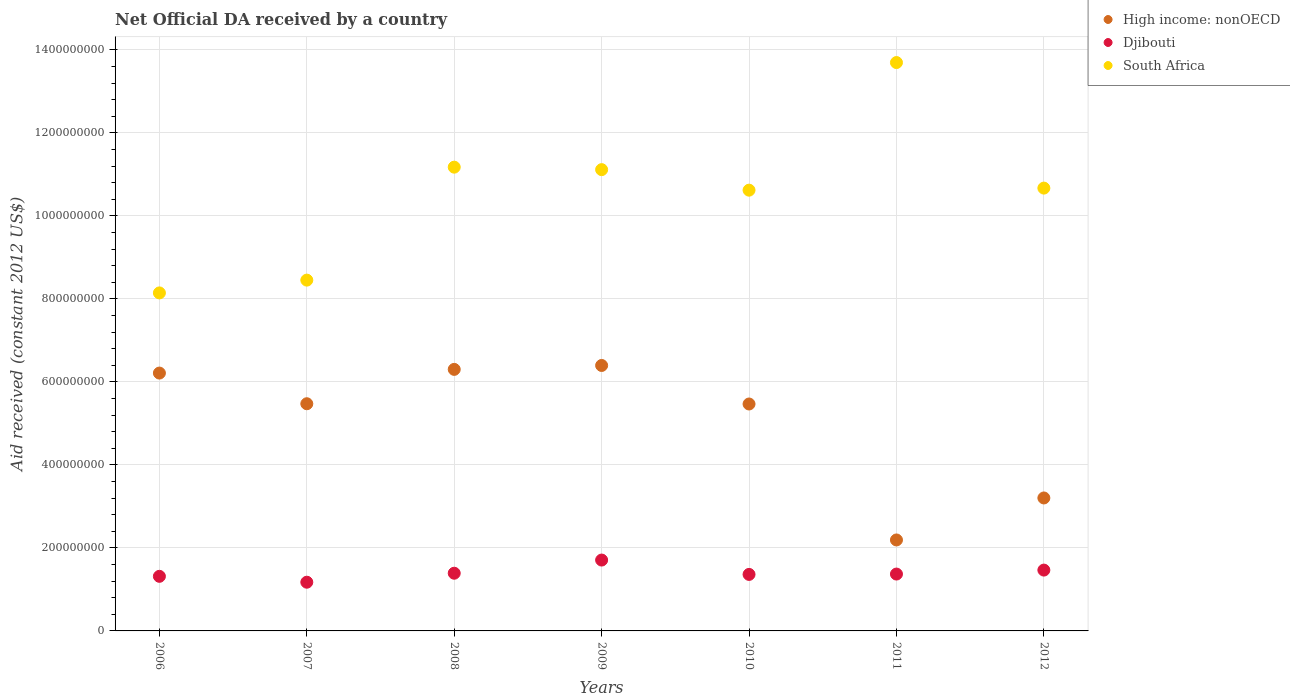Is the number of dotlines equal to the number of legend labels?
Your answer should be compact. Yes. What is the net official development assistance aid received in Djibouti in 2011?
Offer a terse response. 1.37e+08. Across all years, what is the maximum net official development assistance aid received in Djibouti?
Your answer should be compact. 1.71e+08. Across all years, what is the minimum net official development assistance aid received in Djibouti?
Keep it short and to the point. 1.17e+08. What is the total net official development assistance aid received in Djibouti in the graph?
Provide a short and direct response. 9.79e+08. What is the difference between the net official development assistance aid received in South Africa in 2008 and that in 2010?
Make the answer very short. 5.54e+07. What is the difference between the net official development assistance aid received in Djibouti in 2011 and the net official development assistance aid received in South Africa in 2009?
Give a very brief answer. -9.75e+08. What is the average net official development assistance aid received in Djibouti per year?
Make the answer very short. 1.40e+08. In the year 2008, what is the difference between the net official development assistance aid received in High income: nonOECD and net official development assistance aid received in Djibouti?
Your answer should be very brief. 4.91e+08. What is the ratio of the net official development assistance aid received in South Africa in 2007 to that in 2010?
Make the answer very short. 0.8. Is the difference between the net official development assistance aid received in High income: nonOECD in 2006 and 2012 greater than the difference between the net official development assistance aid received in Djibouti in 2006 and 2012?
Your answer should be compact. Yes. What is the difference between the highest and the second highest net official development assistance aid received in South Africa?
Offer a very short reply. 2.52e+08. What is the difference between the highest and the lowest net official development assistance aid received in High income: nonOECD?
Give a very brief answer. 4.20e+08. In how many years, is the net official development assistance aid received in Djibouti greater than the average net official development assistance aid received in Djibouti taken over all years?
Ensure brevity in your answer.  2. Does the net official development assistance aid received in South Africa monotonically increase over the years?
Keep it short and to the point. No. Is the net official development assistance aid received in High income: nonOECD strictly greater than the net official development assistance aid received in Djibouti over the years?
Provide a short and direct response. Yes. Is the net official development assistance aid received in South Africa strictly less than the net official development assistance aid received in Djibouti over the years?
Provide a succinct answer. No. What is the difference between two consecutive major ticks on the Y-axis?
Offer a terse response. 2.00e+08. How are the legend labels stacked?
Ensure brevity in your answer.  Vertical. What is the title of the graph?
Offer a very short reply. Net Official DA received by a country. What is the label or title of the X-axis?
Ensure brevity in your answer.  Years. What is the label or title of the Y-axis?
Give a very brief answer. Aid received (constant 2012 US$). What is the Aid received (constant 2012 US$) in High income: nonOECD in 2006?
Give a very brief answer. 6.21e+08. What is the Aid received (constant 2012 US$) in Djibouti in 2006?
Provide a short and direct response. 1.32e+08. What is the Aid received (constant 2012 US$) in South Africa in 2006?
Your answer should be very brief. 8.15e+08. What is the Aid received (constant 2012 US$) of High income: nonOECD in 2007?
Make the answer very short. 5.47e+08. What is the Aid received (constant 2012 US$) of Djibouti in 2007?
Ensure brevity in your answer.  1.17e+08. What is the Aid received (constant 2012 US$) of South Africa in 2007?
Your answer should be very brief. 8.45e+08. What is the Aid received (constant 2012 US$) in High income: nonOECD in 2008?
Give a very brief answer. 6.30e+08. What is the Aid received (constant 2012 US$) of Djibouti in 2008?
Keep it short and to the point. 1.39e+08. What is the Aid received (constant 2012 US$) in South Africa in 2008?
Offer a very short reply. 1.12e+09. What is the Aid received (constant 2012 US$) in High income: nonOECD in 2009?
Offer a terse response. 6.40e+08. What is the Aid received (constant 2012 US$) in Djibouti in 2009?
Offer a terse response. 1.71e+08. What is the Aid received (constant 2012 US$) in South Africa in 2009?
Offer a very short reply. 1.11e+09. What is the Aid received (constant 2012 US$) of High income: nonOECD in 2010?
Your answer should be very brief. 5.47e+08. What is the Aid received (constant 2012 US$) in Djibouti in 2010?
Offer a very short reply. 1.36e+08. What is the Aid received (constant 2012 US$) of South Africa in 2010?
Your response must be concise. 1.06e+09. What is the Aid received (constant 2012 US$) of High income: nonOECD in 2011?
Ensure brevity in your answer.  2.19e+08. What is the Aid received (constant 2012 US$) in Djibouti in 2011?
Provide a short and direct response. 1.37e+08. What is the Aid received (constant 2012 US$) of South Africa in 2011?
Your response must be concise. 1.37e+09. What is the Aid received (constant 2012 US$) in High income: nonOECD in 2012?
Provide a short and direct response. 3.20e+08. What is the Aid received (constant 2012 US$) of Djibouti in 2012?
Provide a succinct answer. 1.47e+08. What is the Aid received (constant 2012 US$) of South Africa in 2012?
Offer a very short reply. 1.07e+09. Across all years, what is the maximum Aid received (constant 2012 US$) of High income: nonOECD?
Keep it short and to the point. 6.40e+08. Across all years, what is the maximum Aid received (constant 2012 US$) of Djibouti?
Your answer should be very brief. 1.71e+08. Across all years, what is the maximum Aid received (constant 2012 US$) of South Africa?
Your answer should be very brief. 1.37e+09. Across all years, what is the minimum Aid received (constant 2012 US$) of High income: nonOECD?
Provide a short and direct response. 2.19e+08. Across all years, what is the minimum Aid received (constant 2012 US$) in Djibouti?
Offer a terse response. 1.17e+08. Across all years, what is the minimum Aid received (constant 2012 US$) of South Africa?
Give a very brief answer. 8.15e+08. What is the total Aid received (constant 2012 US$) of High income: nonOECD in the graph?
Offer a very short reply. 3.53e+09. What is the total Aid received (constant 2012 US$) of Djibouti in the graph?
Give a very brief answer. 9.79e+08. What is the total Aid received (constant 2012 US$) in South Africa in the graph?
Provide a short and direct response. 7.39e+09. What is the difference between the Aid received (constant 2012 US$) in High income: nonOECD in 2006 and that in 2007?
Provide a short and direct response. 7.39e+07. What is the difference between the Aid received (constant 2012 US$) in Djibouti in 2006 and that in 2007?
Ensure brevity in your answer.  1.42e+07. What is the difference between the Aid received (constant 2012 US$) in South Africa in 2006 and that in 2007?
Provide a succinct answer. -3.08e+07. What is the difference between the Aid received (constant 2012 US$) of High income: nonOECD in 2006 and that in 2008?
Offer a very short reply. -8.90e+06. What is the difference between the Aid received (constant 2012 US$) in Djibouti in 2006 and that in 2008?
Make the answer very short. -7.46e+06. What is the difference between the Aid received (constant 2012 US$) in South Africa in 2006 and that in 2008?
Provide a succinct answer. -3.03e+08. What is the difference between the Aid received (constant 2012 US$) in High income: nonOECD in 2006 and that in 2009?
Ensure brevity in your answer.  -1.83e+07. What is the difference between the Aid received (constant 2012 US$) in Djibouti in 2006 and that in 2009?
Give a very brief answer. -3.92e+07. What is the difference between the Aid received (constant 2012 US$) in South Africa in 2006 and that in 2009?
Give a very brief answer. -2.97e+08. What is the difference between the Aid received (constant 2012 US$) in High income: nonOECD in 2006 and that in 2010?
Your answer should be very brief. 7.45e+07. What is the difference between the Aid received (constant 2012 US$) of Djibouti in 2006 and that in 2010?
Provide a short and direct response. -4.60e+06. What is the difference between the Aid received (constant 2012 US$) of South Africa in 2006 and that in 2010?
Offer a very short reply. -2.48e+08. What is the difference between the Aid received (constant 2012 US$) of High income: nonOECD in 2006 and that in 2011?
Offer a very short reply. 4.02e+08. What is the difference between the Aid received (constant 2012 US$) of Djibouti in 2006 and that in 2011?
Provide a short and direct response. -5.45e+06. What is the difference between the Aid received (constant 2012 US$) of South Africa in 2006 and that in 2011?
Provide a short and direct response. -5.55e+08. What is the difference between the Aid received (constant 2012 US$) of High income: nonOECD in 2006 and that in 2012?
Your answer should be compact. 3.01e+08. What is the difference between the Aid received (constant 2012 US$) of Djibouti in 2006 and that in 2012?
Provide a succinct answer. -1.50e+07. What is the difference between the Aid received (constant 2012 US$) in South Africa in 2006 and that in 2012?
Offer a very short reply. -2.53e+08. What is the difference between the Aid received (constant 2012 US$) of High income: nonOECD in 2007 and that in 2008?
Give a very brief answer. -8.28e+07. What is the difference between the Aid received (constant 2012 US$) of Djibouti in 2007 and that in 2008?
Ensure brevity in your answer.  -2.16e+07. What is the difference between the Aid received (constant 2012 US$) in South Africa in 2007 and that in 2008?
Your answer should be compact. -2.72e+08. What is the difference between the Aid received (constant 2012 US$) of High income: nonOECD in 2007 and that in 2009?
Ensure brevity in your answer.  -9.22e+07. What is the difference between the Aid received (constant 2012 US$) in Djibouti in 2007 and that in 2009?
Your answer should be compact. -5.34e+07. What is the difference between the Aid received (constant 2012 US$) in South Africa in 2007 and that in 2009?
Provide a succinct answer. -2.66e+08. What is the difference between the Aid received (constant 2012 US$) of High income: nonOECD in 2007 and that in 2010?
Offer a terse response. 6.30e+05. What is the difference between the Aid received (constant 2012 US$) of Djibouti in 2007 and that in 2010?
Give a very brief answer. -1.88e+07. What is the difference between the Aid received (constant 2012 US$) of South Africa in 2007 and that in 2010?
Offer a very short reply. -2.17e+08. What is the difference between the Aid received (constant 2012 US$) in High income: nonOECD in 2007 and that in 2011?
Make the answer very short. 3.28e+08. What is the difference between the Aid received (constant 2012 US$) of Djibouti in 2007 and that in 2011?
Make the answer very short. -1.96e+07. What is the difference between the Aid received (constant 2012 US$) of South Africa in 2007 and that in 2011?
Ensure brevity in your answer.  -5.24e+08. What is the difference between the Aid received (constant 2012 US$) of High income: nonOECD in 2007 and that in 2012?
Give a very brief answer. 2.27e+08. What is the difference between the Aid received (constant 2012 US$) of Djibouti in 2007 and that in 2012?
Offer a terse response. -2.92e+07. What is the difference between the Aid received (constant 2012 US$) of South Africa in 2007 and that in 2012?
Keep it short and to the point. -2.22e+08. What is the difference between the Aid received (constant 2012 US$) of High income: nonOECD in 2008 and that in 2009?
Ensure brevity in your answer.  -9.43e+06. What is the difference between the Aid received (constant 2012 US$) of Djibouti in 2008 and that in 2009?
Your response must be concise. -3.17e+07. What is the difference between the Aid received (constant 2012 US$) in South Africa in 2008 and that in 2009?
Ensure brevity in your answer.  5.98e+06. What is the difference between the Aid received (constant 2012 US$) in High income: nonOECD in 2008 and that in 2010?
Offer a very short reply. 8.34e+07. What is the difference between the Aid received (constant 2012 US$) in Djibouti in 2008 and that in 2010?
Offer a very short reply. 2.86e+06. What is the difference between the Aid received (constant 2012 US$) of South Africa in 2008 and that in 2010?
Your answer should be compact. 5.54e+07. What is the difference between the Aid received (constant 2012 US$) of High income: nonOECD in 2008 and that in 2011?
Your response must be concise. 4.11e+08. What is the difference between the Aid received (constant 2012 US$) of Djibouti in 2008 and that in 2011?
Offer a terse response. 2.01e+06. What is the difference between the Aid received (constant 2012 US$) of South Africa in 2008 and that in 2011?
Give a very brief answer. -2.52e+08. What is the difference between the Aid received (constant 2012 US$) in High income: nonOECD in 2008 and that in 2012?
Your response must be concise. 3.10e+08. What is the difference between the Aid received (constant 2012 US$) of Djibouti in 2008 and that in 2012?
Give a very brief answer. -7.55e+06. What is the difference between the Aid received (constant 2012 US$) of South Africa in 2008 and that in 2012?
Offer a terse response. 5.05e+07. What is the difference between the Aid received (constant 2012 US$) of High income: nonOECD in 2009 and that in 2010?
Keep it short and to the point. 9.29e+07. What is the difference between the Aid received (constant 2012 US$) in Djibouti in 2009 and that in 2010?
Provide a short and direct response. 3.46e+07. What is the difference between the Aid received (constant 2012 US$) in South Africa in 2009 and that in 2010?
Your answer should be compact. 4.95e+07. What is the difference between the Aid received (constant 2012 US$) in High income: nonOECD in 2009 and that in 2011?
Make the answer very short. 4.20e+08. What is the difference between the Aid received (constant 2012 US$) of Djibouti in 2009 and that in 2011?
Your answer should be very brief. 3.38e+07. What is the difference between the Aid received (constant 2012 US$) of South Africa in 2009 and that in 2011?
Your response must be concise. -2.58e+08. What is the difference between the Aid received (constant 2012 US$) in High income: nonOECD in 2009 and that in 2012?
Ensure brevity in your answer.  3.19e+08. What is the difference between the Aid received (constant 2012 US$) in Djibouti in 2009 and that in 2012?
Provide a succinct answer. 2.42e+07. What is the difference between the Aid received (constant 2012 US$) of South Africa in 2009 and that in 2012?
Offer a very short reply. 4.45e+07. What is the difference between the Aid received (constant 2012 US$) in High income: nonOECD in 2010 and that in 2011?
Offer a very short reply. 3.28e+08. What is the difference between the Aid received (constant 2012 US$) of Djibouti in 2010 and that in 2011?
Your answer should be compact. -8.50e+05. What is the difference between the Aid received (constant 2012 US$) in South Africa in 2010 and that in 2011?
Ensure brevity in your answer.  -3.08e+08. What is the difference between the Aid received (constant 2012 US$) in High income: nonOECD in 2010 and that in 2012?
Offer a very short reply. 2.26e+08. What is the difference between the Aid received (constant 2012 US$) in Djibouti in 2010 and that in 2012?
Keep it short and to the point. -1.04e+07. What is the difference between the Aid received (constant 2012 US$) in South Africa in 2010 and that in 2012?
Give a very brief answer. -4.97e+06. What is the difference between the Aid received (constant 2012 US$) of High income: nonOECD in 2011 and that in 2012?
Provide a short and direct response. -1.01e+08. What is the difference between the Aid received (constant 2012 US$) of Djibouti in 2011 and that in 2012?
Offer a very short reply. -9.56e+06. What is the difference between the Aid received (constant 2012 US$) in South Africa in 2011 and that in 2012?
Keep it short and to the point. 3.03e+08. What is the difference between the Aid received (constant 2012 US$) in High income: nonOECD in 2006 and the Aid received (constant 2012 US$) in Djibouti in 2007?
Your answer should be very brief. 5.04e+08. What is the difference between the Aid received (constant 2012 US$) of High income: nonOECD in 2006 and the Aid received (constant 2012 US$) of South Africa in 2007?
Ensure brevity in your answer.  -2.24e+08. What is the difference between the Aid received (constant 2012 US$) of Djibouti in 2006 and the Aid received (constant 2012 US$) of South Africa in 2007?
Make the answer very short. -7.14e+08. What is the difference between the Aid received (constant 2012 US$) in High income: nonOECD in 2006 and the Aid received (constant 2012 US$) in Djibouti in 2008?
Your answer should be very brief. 4.82e+08. What is the difference between the Aid received (constant 2012 US$) in High income: nonOECD in 2006 and the Aid received (constant 2012 US$) in South Africa in 2008?
Offer a very short reply. -4.96e+08. What is the difference between the Aid received (constant 2012 US$) in Djibouti in 2006 and the Aid received (constant 2012 US$) in South Africa in 2008?
Make the answer very short. -9.86e+08. What is the difference between the Aid received (constant 2012 US$) in High income: nonOECD in 2006 and the Aid received (constant 2012 US$) in Djibouti in 2009?
Ensure brevity in your answer.  4.51e+08. What is the difference between the Aid received (constant 2012 US$) in High income: nonOECD in 2006 and the Aid received (constant 2012 US$) in South Africa in 2009?
Keep it short and to the point. -4.90e+08. What is the difference between the Aid received (constant 2012 US$) in Djibouti in 2006 and the Aid received (constant 2012 US$) in South Africa in 2009?
Provide a short and direct response. -9.80e+08. What is the difference between the Aid received (constant 2012 US$) of High income: nonOECD in 2006 and the Aid received (constant 2012 US$) of Djibouti in 2010?
Make the answer very short. 4.85e+08. What is the difference between the Aid received (constant 2012 US$) of High income: nonOECD in 2006 and the Aid received (constant 2012 US$) of South Africa in 2010?
Ensure brevity in your answer.  -4.41e+08. What is the difference between the Aid received (constant 2012 US$) in Djibouti in 2006 and the Aid received (constant 2012 US$) in South Africa in 2010?
Make the answer very short. -9.31e+08. What is the difference between the Aid received (constant 2012 US$) in High income: nonOECD in 2006 and the Aid received (constant 2012 US$) in Djibouti in 2011?
Provide a succinct answer. 4.84e+08. What is the difference between the Aid received (constant 2012 US$) of High income: nonOECD in 2006 and the Aid received (constant 2012 US$) of South Africa in 2011?
Keep it short and to the point. -7.48e+08. What is the difference between the Aid received (constant 2012 US$) of Djibouti in 2006 and the Aid received (constant 2012 US$) of South Africa in 2011?
Give a very brief answer. -1.24e+09. What is the difference between the Aid received (constant 2012 US$) in High income: nonOECD in 2006 and the Aid received (constant 2012 US$) in Djibouti in 2012?
Ensure brevity in your answer.  4.75e+08. What is the difference between the Aid received (constant 2012 US$) of High income: nonOECD in 2006 and the Aid received (constant 2012 US$) of South Africa in 2012?
Ensure brevity in your answer.  -4.46e+08. What is the difference between the Aid received (constant 2012 US$) of Djibouti in 2006 and the Aid received (constant 2012 US$) of South Africa in 2012?
Provide a short and direct response. -9.36e+08. What is the difference between the Aid received (constant 2012 US$) of High income: nonOECD in 2007 and the Aid received (constant 2012 US$) of Djibouti in 2008?
Your answer should be very brief. 4.08e+08. What is the difference between the Aid received (constant 2012 US$) of High income: nonOECD in 2007 and the Aid received (constant 2012 US$) of South Africa in 2008?
Give a very brief answer. -5.70e+08. What is the difference between the Aid received (constant 2012 US$) of Djibouti in 2007 and the Aid received (constant 2012 US$) of South Africa in 2008?
Keep it short and to the point. -1.00e+09. What is the difference between the Aid received (constant 2012 US$) in High income: nonOECD in 2007 and the Aid received (constant 2012 US$) in Djibouti in 2009?
Your answer should be compact. 3.77e+08. What is the difference between the Aid received (constant 2012 US$) of High income: nonOECD in 2007 and the Aid received (constant 2012 US$) of South Africa in 2009?
Your answer should be very brief. -5.64e+08. What is the difference between the Aid received (constant 2012 US$) of Djibouti in 2007 and the Aid received (constant 2012 US$) of South Africa in 2009?
Give a very brief answer. -9.94e+08. What is the difference between the Aid received (constant 2012 US$) of High income: nonOECD in 2007 and the Aid received (constant 2012 US$) of Djibouti in 2010?
Ensure brevity in your answer.  4.11e+08. What is the difference between the Aid received (constant 2012 US$) of High income: nonOECD in 2007 and the Aid received (constant 2012 US$) of South Africa in 2010?
Offer a terse response. -5.15e+08. What is the difference between the Aid received (constant 2012 US$) in Djibouti in 2007 and the Aid received (constant 2012 US$) in South Africa in 2010?
Ensure brevity in your answer.  -9.45e+08. What is the difference between the Aid received (constant 2012 US$) of High income: nonOECD in 2007 and the Aid received (constant 2012 US$) of Djibouti in 2011?
Give a very brief answer. 4.10e+08. What is the difference between the Aid received (constant 2012 US$) in High income: nonOECD in 2007 and the Aid received (constant 2012 US$) in South Africa in 2011?
Offer a very short reply. -8.22e+08. What is the difference between the Aid received (constant 2012 US$) in Djibouti in 2007 and the Aid received (constant 2012 US$) in South Africa in 2011?
Offer a terse response. -1.25e+09. What is the difference between the Aid received (constant 2012 US$) in High income: nonOECD in 2007 and the Aid received (constant 2012 US$) in Djibouti in 2012?
Your response must be concise. 4.01e+08. What is the difference between the Aid received (constant 2012 US$) in High income: nonOECD in 2007 and the Aid received (constant 2012 US$) in South Africa in 2012?
Your answer should be compact. -5.20e+08. What is the difference between the Aid received (constant 2012 US$) of Djibouti in 2007 and the Aid received (constant 2012 US$) of South Africa in 2012?
Keep it short and to the point. -9.50e+08. What is the difference between the Aid received (constant 2012 US$) of High income: nonOECD in 2008 and the Aid received (constant 2012 US$) of Djibouti in 2009?
Your response must be concise. 4.60e+08. What is the difference between the Aid received (constant 2012 US$) in High income: nonOECD in 2008 and the Aid received (constant 2012 US$) in South Africa in 2009?
Offer a terse response. -4.81e+08. What is the difference between the Aid received (constant 2012 US$) in Djibouti in 2008 and the Aid received (constant 2012 US$) in South Africa in 2009?
Provide a short and direct response. -9.73e+08. What is the difference between the Aid received (constant 2012 US$) of High income: nonOECD in 2008 and the Aid received (constant 2012 US$) of Djibouti in 2010?
Your answer should be very brief. 4.94e+08. What is the difference between the Aid received (constant 2012 US$) in High income: nonOECD in 2008 and the Aid received (constant 2012 US$) in South Africa in 2010?
Your answer should be very brief. -4.32e+08. What is the difference between the Aid received (constant 2012 US$) in Djibouti in 2008 and the Aid received (constant 2012 US$) in South Africa in 2010?
Your response must be concise. -9.23e+08. What is the difference between the Aid received (constant 2012 US$) of High income: nonOECD in 2008 and the Aid received (constant 2012 US$) of Djibouti in 2011?
Make the answer very short. 4.93e+08. What is the difference between the Aid received (constant 2012 US$) of High income: nonOECD in 2008 and the Aid received (constant 2012 US$) of South Africa in 2011?
Make the answer very short. -7.39e+08. What is the difference between the Aid received (constant 2012 US$) of Djibouti in 2008 and the Aid received (constant 2012 US$) of South Africa in 2011?
Make the answer very short. -1.23e+09. What is the difference between the Aid received (constant 2012 US$) of High income: nonOECD in 2008 and the Aid received (constant 2012 US$) of Djibouti in 2012?
Provide a short and direct response. 4.84e+08. What is the difference between the Aid received (constant 2012 US$) of High income: nonOECD in 2008 and the Aid received (constant 2012 US$) of South Africa in 2012?
Ensure brevity in your answer.  -4.37e+08. What is the difference between the Aid received (constant 2012 US$) of Djibouti in 2008 and the Aid received (constant 2012 US$) of South Africa in 2012?
Your answer should be very brief. -9.28e+08. What is the difference between the Aid received (constant 2012 US$) in High income: nonOECD in 2009 and the Aid received (constant 2012 US$) in Djibouti in 2010?
Your answer should be very brief. 5.04e+08. What is the difference between the Aid received (constant 2012 US$) of High income: nonOECD in 2009 and the Aid received (constant 2012 US$) of South Africa in 2010?
Your answer should be very brief. -4.22e+08. What is the difference between the Aid received (constant 2012 US$) of Djibouti in 2009 and the Aid received (constant 2012 US$) of South Africa in 2010?
Make the answer very short. -8.91e+08. What is the difference between the Aid received (constant 2012 US$) in High income: nonOECD in 2009 and the Aid received (constant 2012 US$) in Djibouti in 2011?
Offer a terse response. 5.03e+08. What is the difference between the Aid received (constant 2012 US$) of High income: nonOECD in 2009 and the Aid received (constant 2012 US$) of South Africa in 2011?
Make the answer very short. -7.30e+08. What is the difference between the Aid received (constant 2012 US$) of Djibouti in 2009 and the Aid received (constant 2012 US$) of South Africa in 2011?
Your answer should be compact. -1.20e+09. What is the difference between the Aid received (constant 2012 US$) in High income: nonOECD in 2009 and the Aid received (constant 2012 US$) in Djibouti in 2012?
Keep it short and to the point. 4.93e+08. What is the difference between the Aid received (constant 2012 US$) of High income: nonOECD in 2009 and the Aid received (constant 2012 US$) of South Africa in 2012?
Provide a succinct answer. -4.27e+08. What is the difference between the Aid received (constant 2012 US$) of Djibouti in 2009 and the Aid received (constant 2012 US$) of South Africa in 2012?
Keep it short and to the point. -8.96e+08. What is the difference between the Aid received (constant 2012 US$) in High income: nonOECD in 2010 and the Aid received (constant 2012 US$) in Djibouti in 2011?
Ensure brevity in your answer.  4.10e+08. What is the difference between the Aid received (constant 2012 US$) in High income: nonOECD in 2010 and the Aid received (constant 2012 US$) in South Africa in 2011?
Make the answer very short. -8.23e+08. What is the difference between the Aid received (constant 2012 US$) of Djibouti in 2010 and the Aid received (constant 2012 US$) of South Africa in 2011?
Your answer should be compact. -1.23e+09. What is the difference between the Aid received (constant 2012 US$) in High income: nonOECD in 2010 and the Aid received (constant 2012 US$) in Djibouti in 2012?
Your answer should be compact. 4.00e+08. What is the difference between the Aid received (constant 2012 US$) of High income: nonOECD in 2010 and the Aid received (constant 2012 US$) of South Africa in 2012?
Provide a short and direct response. -5.20e+08. What is the difference between the Aid received (constant 2012 US$) in Djibouti in 2010 and the Aid received (constant 2012 US$) in South Africa in 2012?
Make the answer very short. -9.31e+08. What is the difference between the Aid received (constant 2012 US$) in High income: nonOECD in 2011 and the Aid received (constant 2012 US$) in Djibouti in 2012?
Your answer should be very brief. 7.26e+07. What is the difference between the Aid received (constant 2012 US$) in High income: nonOECD in 2011 and the Aid received (constant 2012 US$) in South Africa in 2012?
Your response must be concise. -8.48e+08. What is the difference between the Aid received (constant 2012 US$) in Djibouti in 2011 and the Aid received (constant 2012 US$) in South Africa in 2012?
Your response must be concise. -9.30e+08. What is the average Aid received (constant 2012 US$) of High income: nonOECD per year?
Your answer should be very brief. 5.04e+08. What is the average Aid received (constant 2012 US$) in Djibouti per year?
Offer a very short reply. 1.40e+08. What is the average Aid received (constant 2012 US$) in South Africa per year?
Provide a short and direct response. 1.06e+09. In the year 2006, what is the difference between the Aid received (constant 2012 US$) in High income: nonOECD and Aid received (constant 2012 US$) in Djibouti?
Offer a terse response. 4.90e+08. In the year 2006, what is the difference between the Aid received (constant 2012 US$) in High income: nonOECD and Aid received (constant 2012 US$) in South Africa?
Your answer should be very brief. -1.93e+08. In the year 2006, what is the difference between the Aid received (constant 2012 US$) of Djibouti and Aid received (constant 2012 US$) of South Africa?
Your answer should be compact. -6.83e+08. In the year 2007, what is the difference between the Aid received (constant 2012 US$) of High income: nonOECD and Aid received (constant 2012 US$) of Djibouti?
Give a very brief answer. 4.30e+08. In the year 2007, what is the difference between the Aid received (constant 2012 US$) in High income: nonOECD and Aid received (constant 2012 US$) in South Africa?
Your answer should be very brief. -2.98e+08. In the year 2007, what is the difference between the Aid received (constant 2012 US$) of Djibouti and Aid received (constant 2012 US$) of South Africa?
Offer a terse response. -7.28e+08. In the year 2008, what is the difference between the Aid received (constant 2012 US$) of High income: nonOECD and Aid received (constant 2012 US$) of Djibouti?
Provide a short and direct response. 4.91e+08. In the year 2008, what is the difference between the Aid received (constant 2012 US$) in High income: nonOECD and Aid received (constant 2012 US$) in South Africa?
Give a very brief answer. -4.87e+08. In the year 2008, what is the difference between the Aid received (constant 2012 US$) of Djibouti and Aid received (constant 2012 US$) of South Africa?
Make the answer very short. -9.79e+08. In the year 2009, what is the difference between the Aid received (constant 2012 US$) of High income: nonOECD and Aid received (constant 2012 US$) of Djibouti?
Keep it short and to the point. 4.69e+08. In the year 2009, what is the difference between the Aid received (constant 2012 US$) in High income: nonOECD and Aid received (constant 2012 US$) in South Africa?
Provide a succinct answer. -4.72e+08. In the year 2009, what is the difference between the Aid received (constant 2012 US$) in Djibouti and Aid received (constant 2012 US$) in South Africa?
Your response must be concise. -9.41e+08. In the year 2010, what is the difference between the Aid received (constant 2012 US$) in High income: nonOECD and Aid received (constant 2012 US$) in Djibouti?
Make the answer very short. 4.11e+08. In the year 2010, what is the difference between the Aid received (constant 2012 US$) in High income: nonOECD and Aid received (constant 2012 US$) in South Africa?
Offer a very short reply. -5.15e+08. In the year 2010, what is the difference between the Aid received (constant 2012 US$) in Djibouti and Aid received (constant 2012 US$) in South Africa?
Your response must be concise. -9.26e+08. In the year 2011, what is the difference between the Aid received (constant 2012 US$) in High income: nonOECD and Aid received (constant 2012 US$) in Djibouti?
Your answer should be compact. 8.22e+07. In the year 2011, what is the difference between the Aid received (constant 2012 US$) in High income: nonOECD and Aid received (constant 2012 US$) in South Africa?
Your answer should be compact. -1.15e+09. In the year 2011, what is the difference between the Aid received (constant 2012 US$) of Djibouti and Aid received (constant 2012 US$) of South Africa?
Provide a succinct answer. -1.23e+09. In the year 2012, what is the difference between the Aid received (constant 2012 US$) in High income: nonOECD and Aid received (constant 2012 US$) in Djibouti?
Provide a succinct answer. 1.74e+08. In the year 2012, what is the difference between the Aid received (constant 2012 US$) of High income: nonOECD and Aid received (constant 2012 US$) of South Africa?
Offer a very short reply. -7.47e+08. In the year 2012, what is the difference between the Aid received (constant 2012 US$) in Djibouti and Aid received (constant 2012 US$) in South Africa?
Give a very brief answer. -9.21e+08. What is the ratio of the Aid received (constant 2012 US$) in High income: nonOECD in 2006 to that in 2007?
Provide a succinct answer. 1.14. What is the ratio of the Aid received (constant 2012 US$) of Djibouti in 2006 to that in 2007?
Make the answer very short. 1.12. What is the ratio of the Aid received (constant 2012 US$) of South Africa in 2006 to that in 2007?
Keep it short and to the point. 0.96. What is the ratio of the Aid received (constant 2012 US$) in High income: nonOECD in 2006 to that in 2008?
Ensure brevity in your answer.  0.99. What is the ratio of the Aid received (constant 2012 US$) in Djibouti in 2006 to that in 2008?
Your answer should be very brief. 0.95. What is the ratio of the Aid received (constant 2012 US$) in South Africa in 2006 to that in 2008?
Provide a succinct answer. 0.73. What is the ratio of the Aid received (constant 2012 US$) of High income: nonOECD in 2006 to that in 2009?
Provide a succinct answer. 0.97. What is the ratio of the Aid received (constant 2012 US$) of Djibouti in 2006 to that in 2009?
Provide a succinct answer. 0.77. What is the ratio of the Aid received (constant 2012 US$) of South Africa in 2006 to that in 2009?
Give a very brief answer. 0.73. What is the ratio of the Aid received (constant 2012 US$) of High income: nonOECD in 2006 to that in 2010?
Offer a terse response. 1.14. What is the ratio of the Aid received (constant 2012 US$) in Djibouti in 2006 to that in 2010?
Provide a succinct answer. 0.97. What is the ratio of the Aid received (constant 2012 US$) of South Africa in 2006 to that in 2010?
Offer a very short reply. 0.77. What is the ratio of the Aid received (constant 2012 US$) in High income: nonOECD in 2006 to that in 2011?
Make the answer very short. 2.83. What is the ratio of the Aid received (constant 2012 US$) of Djibouti in 2006 to that in 2011?
Provide a succinct answer. 0.96. What is the ratio of the Aid received (constant 2012 US$) of South Africa in 2006 to that in 2011?
Give a very brief answer. 0.59. What is the ratio of the Aid received (constant 2012 US$) in High income: nonOECD in 2006 to that in 2012?
Your response must be concise. 1.94. What is the ratio of the Aid received (constant 2012 US$) in Djibouti in 2006 to that in 2012?
Your answer should be compact. 0.9. What is the ratio of the Aid received (constant 2012 US$) in South Africa in 2006 to that in 2012?
Keep it short and to the point. 0.76. What is the ratio of the Aid received (constant 2012 US$) of High income: nonOECD in 2007 to that in 2008?
Provide a succinct answer. 0.87. What is the ratio of the Aid received (constant 2012 US$) in Djibouti in 2007 to that in 2008?
Provide a succinct answer. 0.84. What is the ratio of the Aid received (constant 2012 US$) in South Africa in 2007 to that in 2008?
Your answer should be compact. 0.76. What is the ratio of the Aid received (constant 2012 US$) of High income: nonOECD in 2007 to that in 2009?
Give a very brief answer. 0.86. What is the ratio of the Aid received (constant 2012 US$) of Djibouti in 2007 to that in 2009?
Offer a terse response. 0.69. What is the ratio of the Aid received (constant 2012 US$) in South Africa in 2007 to that in 2009?
Provide a succinct answer. 0.76. What is the ratio of the Aid received (constant 2012 US$) in High income: nonOECD in 2007 to that in 2010?
Your answer should be compact. 1. What is the ratio of the Aid received (constant 2012 US$) of Djibouti in 2007 to that in 2010?
Your answer should be compact. 0.86. What is the ratio of the Aid received (constant 2012 US$) of South Africa in 2007 to that in 2010?
Provide a succinct answer. 0.8. What is the ratio of the Aid received (constant 2012 US$) in High income: nonOECD in 2007 to that in 2011?
Provide a short and direct response. 2.5. What is the ratio of the Aid received (constant 2012 US$) of Djibouti in 2007 to that in 2011?
Offer a terse response. 0.86. What is the ratio of the Aid received (constant 2012 US$) in South Africa in 2007 to that in 2011?
Give a very brief answer. 0.62. What is the ratio of the Aid received (constant 2012 US$) in High income: nonOECD in 2007 to that in 2012?
Provide a succinct answer. 1.71. What is the ratio of the Aid received (constant 2012 US$) in Djibouti in 2007 to that in 2012?
Your answer should be very brief. 0.8. What is the ratio of the Aid received (constant 2012 US$) of South Africa in 2007 to that in 2012?
Provide a succinct answer. 0.79. What is the ratio of the Aid received (constant 2012 US$) of Djibouti in 2008 to that in 2009?
Your answer should be compact. 0.81. What is the ratio of the Aid received (constant 2012 US$) of South Africa in 2008 to that in 2009?
Make the answer very short. 1.01. What is the ratio of the Aid received (constant 2012 US$) in High income: nonOECD in 2008 to that in 2010?
Offer a terse response. 1.15. What is the ratio of the Aid received (constant 2012 US$) of South Africa in 2008 to that in 2010?
Your answer should be very brief. 1.05. What is the ratio of the Aid received (constant 2012 US$) in High income: nonOECD in 2008 to that in 2011?
Give a very brief answer. 2.88. What is the ratio of the Aid received (constant 2012 US$) of Djibouti in 2008 to that in 2011?
Offer a terse response. 1.01. What is the ratio of the Aid received (constant 2012 US$) in South Africa in 2008 to that in 2011?
Your answer should be very brief. 0.82. What is the ratio of the Aid received (constant 2012 US$) in High income: nonOECD in 2008 to that in 2012?
Your answer should be compact. 1.97. What is the ratio of the Aid received (constant 2012 US$) in Djibouti in 2008 to that in 2012?
Ensure brevity in your answer.  0.95. What is the ratio of the Aid received (constant 2012 US$) in South Africa in 2008 to that in 2012?
Give a very brief answer. 1.05. What is the ratio of the Aid received (constant 2012 US$) of High income: nonOECD in 2009 to that in 2010?
Your answer should be very brief. 1.17. What is the ratio of the Aid received (constant 2012 US$) of Djibouti in 2009 to that in 2010?
Ensure brevity in your answer.  1.25. What is the ratio of the Aid received (constant 2012 US$) in South Africa in 2009 to that in 2010?
Keep it short and to the point. 1.05. What is the ratio of the Aid received (constant 2012 US$) in High income: nonOECD in 2009 to that in 2011?
Offer a terse response. 2.92. What is the ratio of the Aid received (constant 2012 US$) in Djibouti in 2009 to that in 2011?
Offer a very short reply. 1.25. What is the ratio of the Aid received (constant 2012 US$) of South Africa in 2009 to that in 2011?
Your answer should be very brief. 0.81. What is the ratio of the Aid received (constant 2012 US$) of High income: nonOECD in 2009 to that in 2012?
Provide a short and direct response. 2. What is the ratio of the Aid received (constant 2012 US$) of Djibouti in 2009 to that in 2012?
Offer a very short reply. 1.17. What is the ratio of the Aid received (constant 2012 US$) of South Africa in 2009 to that in 2012?
Provide a succinct answer. 1.04. What is the ratio of the Aid received (constant 2012 US$) of High income: nonOECD in 2010 to that in 2011?
Offer a terse response. 2.49. What is the ratio of the Aid received (constant 2012 US$) of Djibouti in 2010 to that in 2011?
Make the answer very short. 0.99. What is the ratio of the Aid received (constant 2012 US$) of South Africa in 2010 to that in 2011?
Your response must be concise. 0.78. What is the ratio of the Aid received (constant 2012 US$) of High income: nonOECD in 2010 to that in 2012?
Make the answer very short. 1.71. What is the ratio of the Aid received (constant 2012 US$) in Djibouti in 2010 to that in 2012?
Provide a succinct answer. 0.93. What is the ratio of the Aid received (constant 2012 US$) in High income: nonOECD in 2011 to that in 2012?
Offer a very short reply. 0.68. What is the ratio of the Aid received (constant 2012 US$) in Djibouti in 2011 to that in 2012?
Offer a very short reply. 0.93. What is the ratio of the Aid received (constant 2012 US$) of South Africa in 2011 to that in 2012?
Ensure brevity in your answer.  1.28. What is the difference between the highest and the second highest Aid received (constant 2012 US$) in High income: nonOECD?
Offer a terse response. 9.43e+06. What is the difference between the highest and the second highest Aid received (constant 2012 US$) of Djibouti?
Your answer should be compact. 2.42e+07. What is the difference between the highest and the second highest Aid received (constant 2012 US$) of South Africa?
Offer a very short reply. 2.52e+08. What is the difference between the highest and the lowest Aid received (constant 2012 US$) of High income: nonOECD?
Offer a very short reply. 4.20e+08. What is the difference between the highest and the lowest Aid received (constant 2012 US$) of Djibouti?
Ensure brevity in your answer.  5.34e+07. What is the difference between the highest and the lowest Aid received (constant 2012 US$) of South Africa?
Offer a terse response. 5.55e+08. 